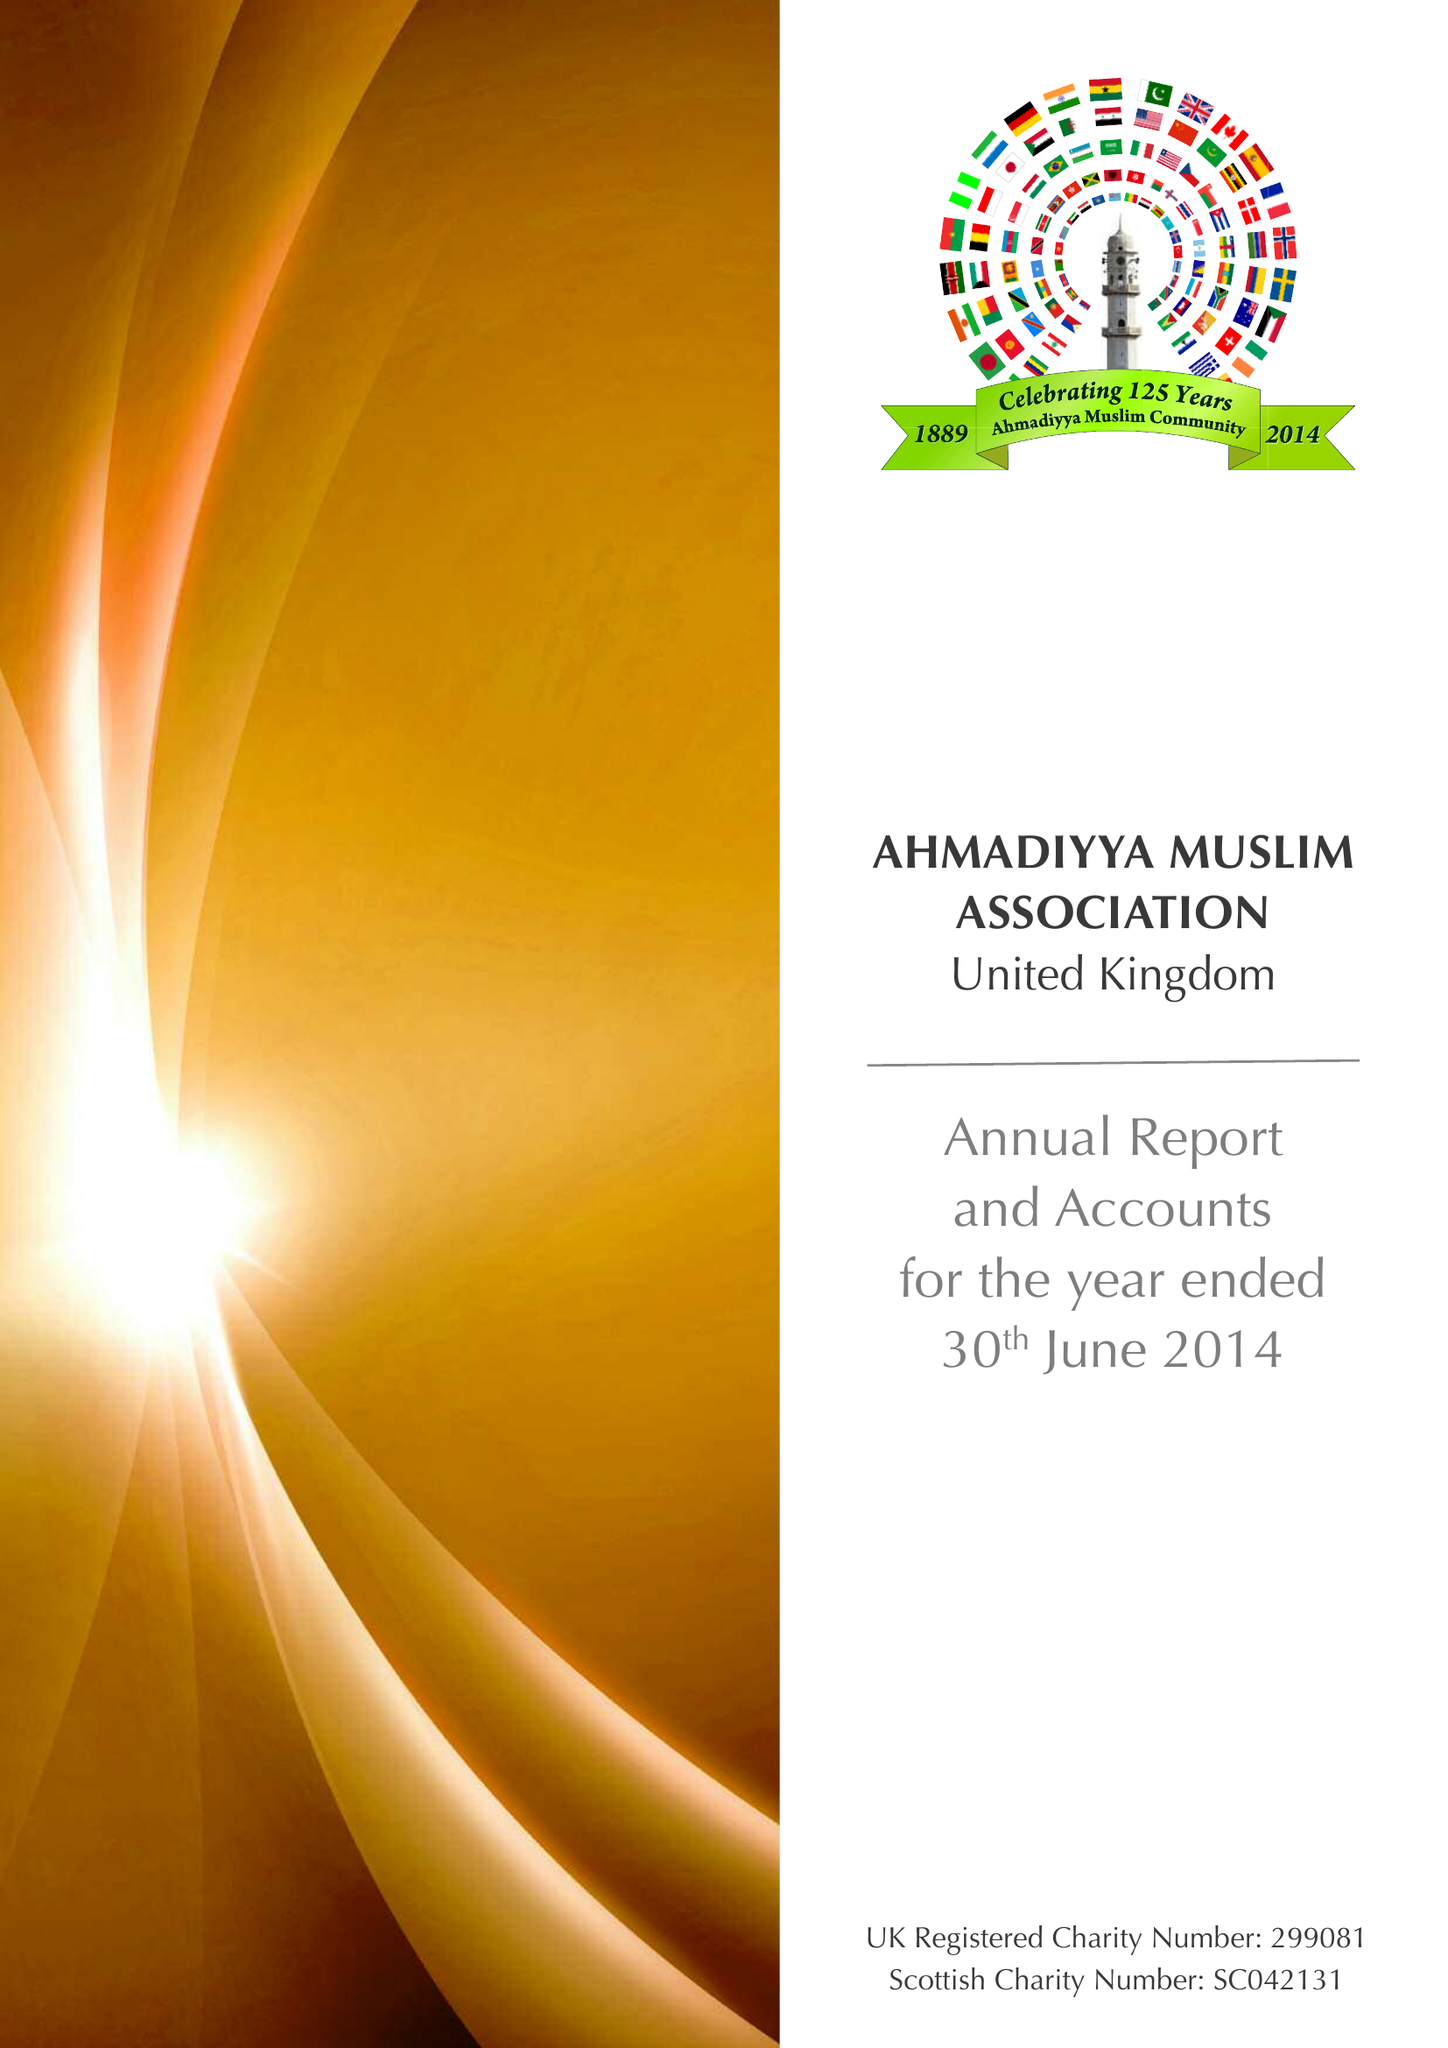What is the value for the income_annually_in_british_pounds?
Answer the question using a single word or phrase. 13910600.00 